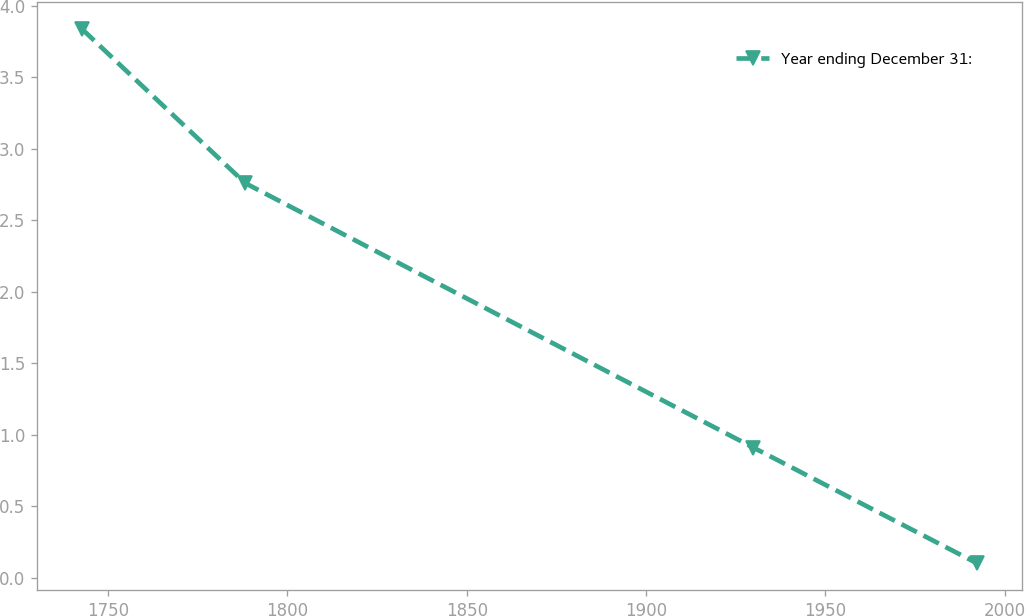Convert chart to OTSL. <chart><loc_0><loc_0><loc_500><loc_500><line_chart><ecel><fcel>Year ending December 31:<nl><fcel>1742.64<fcel>3.84<nl><fcel>1788.23<fcel>2.76<nl><fcel>1929.96<fcel>0.91<nl><fcel>1992.4<fcel>0.1<nl></chart> 